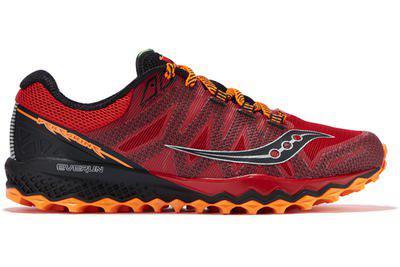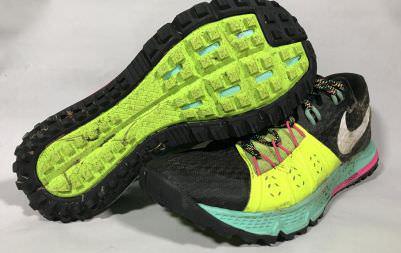The first image is the image on the left, the second image is the image on the right. Given the left and right images, does the statement "the left image has one shoe pointing to the right" hold true? Answer yes or no. Yes. 